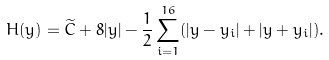<formula> <loc_0><loc_0><loc_500><loc_500>H ( y ) = \widetilde { C } + 8 | y | - \frac { 1 } { 2 } \sum _ { i = 1 } ^ { 1 6 } ( | y - y _ { i } | + | y + y _ { i } | ) .</formula> 